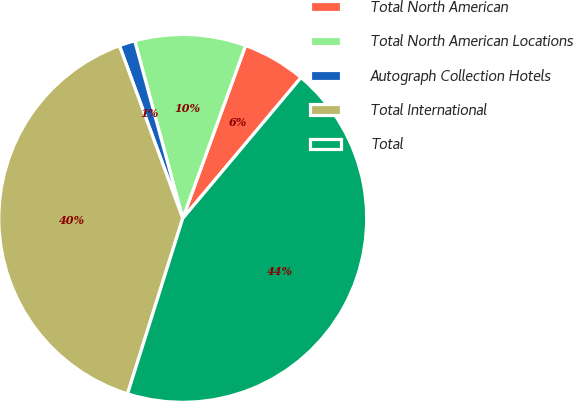Convert chart to OTSL. <chart><loc_0><loc_0><loc_500><loc_500><pie_chart><fcel>Total North American<fcel>Total North American Locations<fcel>Autograph Collection Hotels<fcel>Total International<fcel>Total<nl><fcel>5.57%<fcel>9.75%<fcel>1.39%<fcel>39.55%<fcel>43.73%<nl></chart> 